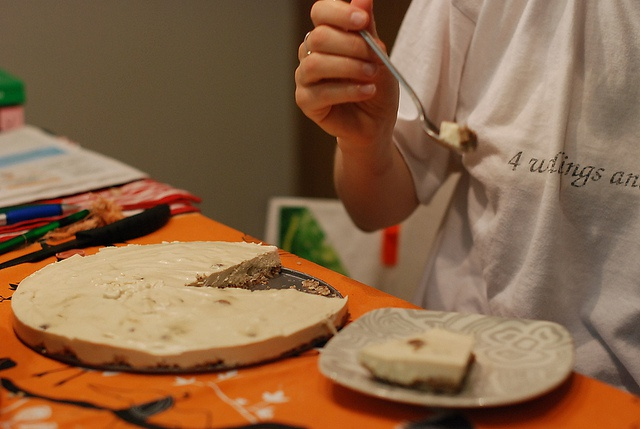Describe the objects in this image and their specific colors. I can see dining table in gray, tan, red, and brown tones, people in gray and maroon tones, cake in gray, tan, brown, and maroon tones, cake in gray, tan, and olive tones, and knife in gray, black, maroon, brown, and red tones in this image. 